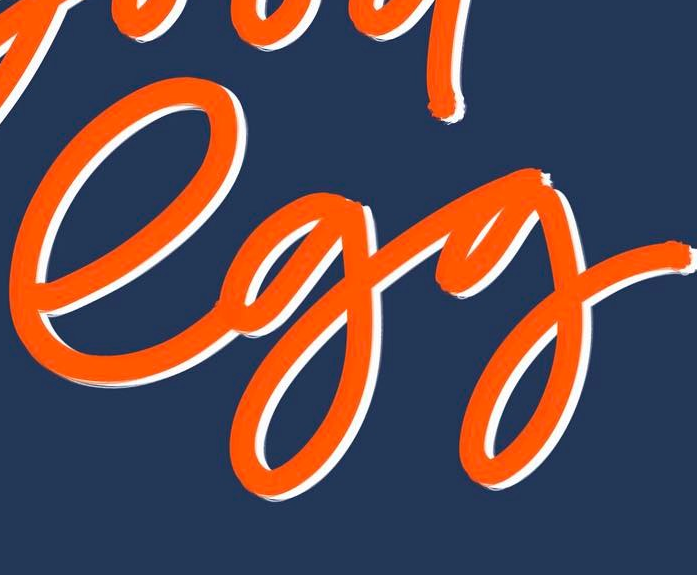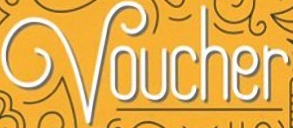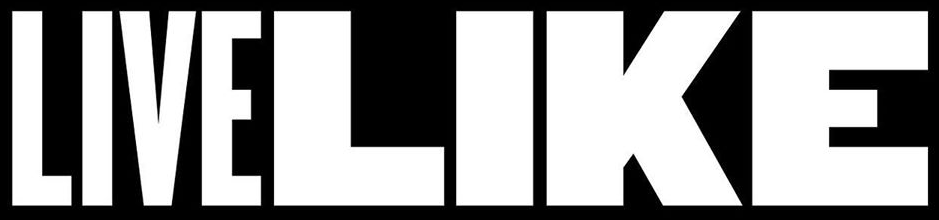What text appears in these images from left to right, separated by a semicolon? egg; Voucher; LIVELIKE 